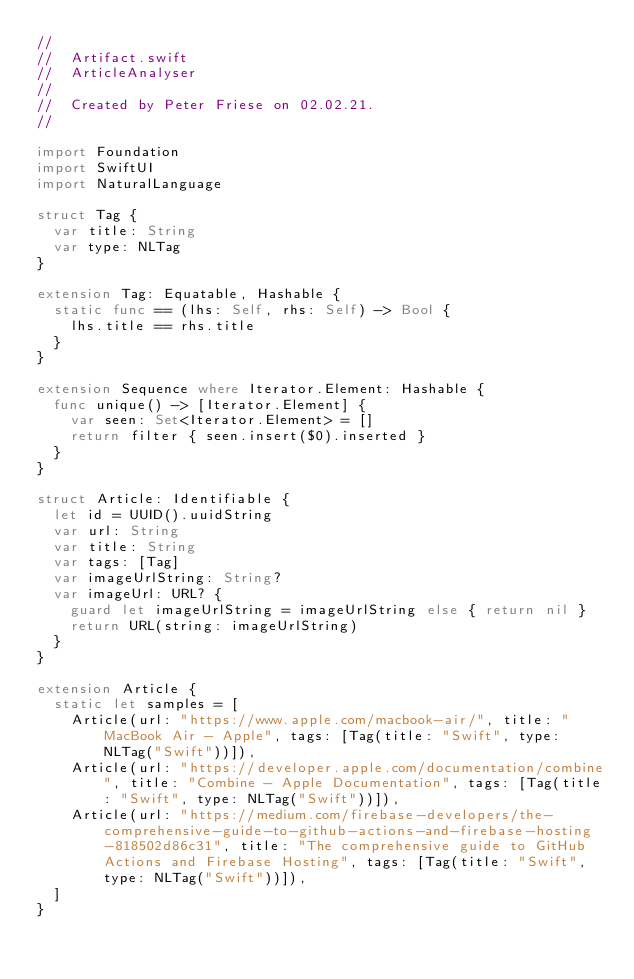Convert code to text. <code><loc_0><loc_0><loc_500><loc_500><_Swift_>//
//  Artifact.swift
//  ArticleAnalyser
//
//  Created by Peter Friese on 02.02.21.
//

import Foundation
import SwiftUI
import NaturalLanguage

struct Tag {
  var title: String
  var type: NLTag
}

extension Tag: Equatable, Hashable {
  static func == (lhs: Self, rhs: Self) -> Bool {
    lhs.title == rhs.title
  }
}

extension Sequence where Iterator.Element: Hashable {
  func unique() -> [Iterator.Element] {
    var seen: Set<Iterator.Element> = []
    return filter { seen.insert($0).inserted }
  }
}

struct Article: Identifiable {
  let id = UUID().uuidString
  var url: String
  var title: String
  var tags: [Tag]
  var imageUrlString: String?
  var imageUrl: URL? {
    guard let imageUrlString = imageUrlString else { return nil }
    return URL(string: imageUrlString)
  }
}

extension Article {
  static let samples = [
    Article(url: "https://www.apple.com/macbook-air/", title: "MacBook Air - Apple", tags: [Tag(title: "Swift", type: NLTag("Swift"))]),
    Article(url: "https://developer.apple.com/documentation/combine", title: "Combine - Apple Documentation", tags: [Tag(title: "Swift", type: NLTag("Swift"))]),
    Article(url: "https://medium.com/firebase-developers/the-comprehensive-guide-to-github-actions-and-firebase-hosting-818502d86c31", title: "The comprehensive guide to GitHub Actions and Firebase Hosting", tags: [Tag(title: "Swift", type: NLTag("Swift"))]),
  ]
}
</code> 